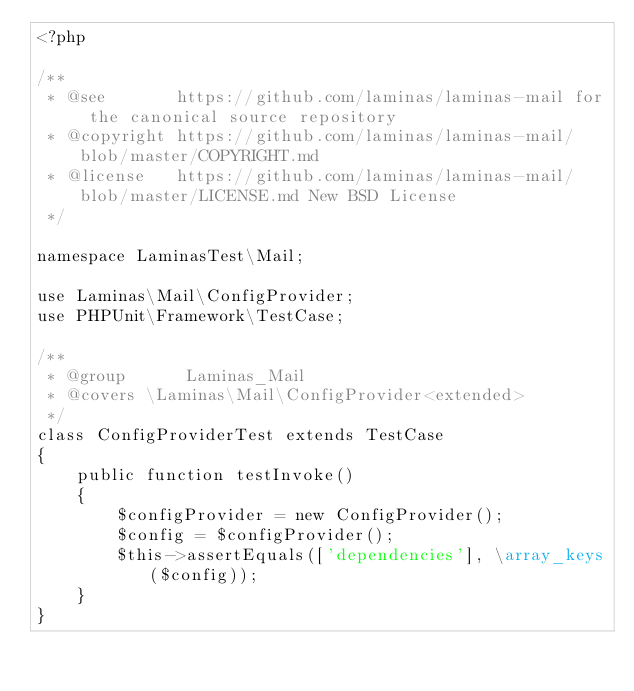<code> <loc_0><loc_0><loc_500><loc_500><_PHP_><?php

/**
 * @see       https://github.com/laminas/laminas-mail for the canonical source repository
 * @copyright https://github.com/laminas/laminas-mail/blob/master/COPYRIGHT.md
 * @license   https://github.com/laminas/laminas-mail/blob/master/LICENSE.md New BSD License
 */

namespace LaminasTest\Mail;

use Laminas\Mail\ConfigProvider;
use PHPUnit\Framework\TestCase;

/**
 * @group      Laminas_Mail
 * @covers \Laminas\Mail\ConfigProvider<extended>
 */
class ConfigProviderTest extends TestCase
{
    public function testInvoke()
    {
        $configProvider = new ConfigProvider();
        $config = $configProvider();
        $this->assertEquals(['dependencies'], \array_keys($config));
    }
}
</code> 